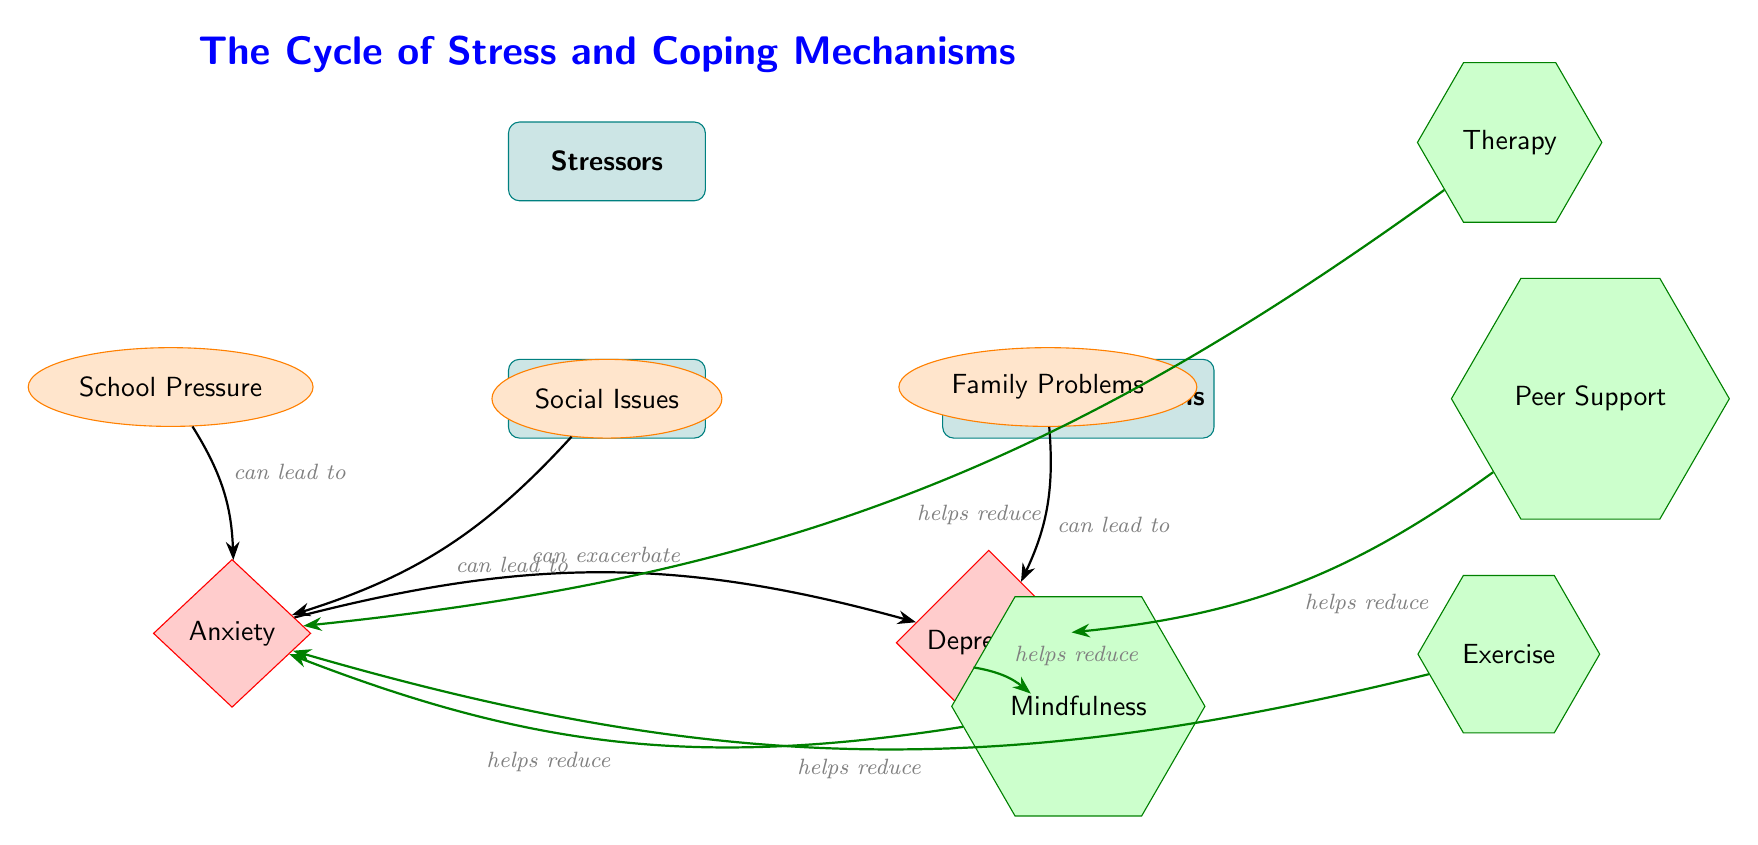What are the three stressors identified in the diagram? The diagram lists three stressors: School Pressure, Social Issues, and Family Problems. By directly referring to the stressor nodes in the diagram, we can easily identify them.
Answer: School Pressure, Social Issues, Family Problems How many symptoms of anxiety and depression are depicted? The diagram presents two symptoms: Anxiety and Depression. By counting the symptom nodes, we confirm that there are indeed two symptoms represented.
Answer: 2 What mechanism is shown to specifically help reduce depression? The diagram indicates that Peer Support is a coping mechanism that helps reduce depression. This can be found by looking at the connections from coping mechanisms to symptoms.
Answer: Peer Support Which stressor can lead to both anxiety and depression? The Family Problems stressor is directly connected to Depression while its impact on single symptoms is not stated, however, through anxiety connections we can note this as well. Thus, it concludes with this.
Answer: Family Problems Which coping mechanism helps reduce both anxiety and depression? Mindfulness is shown in the diagram to reduce both Anxiety and Depression. This is determined by following the arrows that connect Mindfulness to both symptom nodes.
Answer: Mindfulness What relationship exists between anxiety and depression according to the diagram? The diagram illustrates that Anxiety can exacerbate Depression. This is identified through following the arrows from the Anxiety symptom node to the Depression symptom node.
Answer: Can exacerbate Which coping mechanism is indicated to help reduce anxiety? There are multiple mechanisms, including Therapy, Exercise, and Mindfulness, which help reduce anxiety. All these can be seen pointing towards the Anxiety symptom node in the diagram.
Answer: Therapy, Exercise, Mindfulness What type of shape represents stressors in the diagram? Stressors are represented by ellipses in the diagram. This can be concluded by identifying the specific shapes designated for stressors as described in the legend of the diagram.
Answer: Ellipses How many coping mechanisms are shown in the diagram? There are four coping mechanisms: Therapy, Peer Support, Exercise, and Mindfulness. By counting the mechanism nodes, we find all four clearly labeled in the coping section.
Answer: 4 What color represents the symptoms in the diagram? Symptoms are shown with a red fill in the diagram. This can be derived from identifying the typical color coding in the legend for each category of nodes.
Answer: Red 